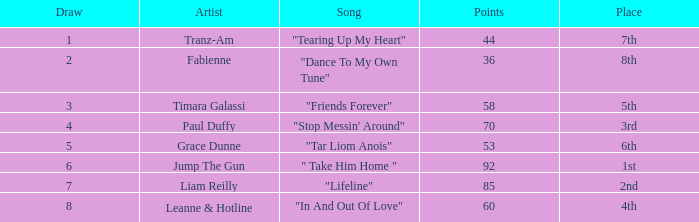What's the highest draw with over 60 points for paul duffy? 4.0. 